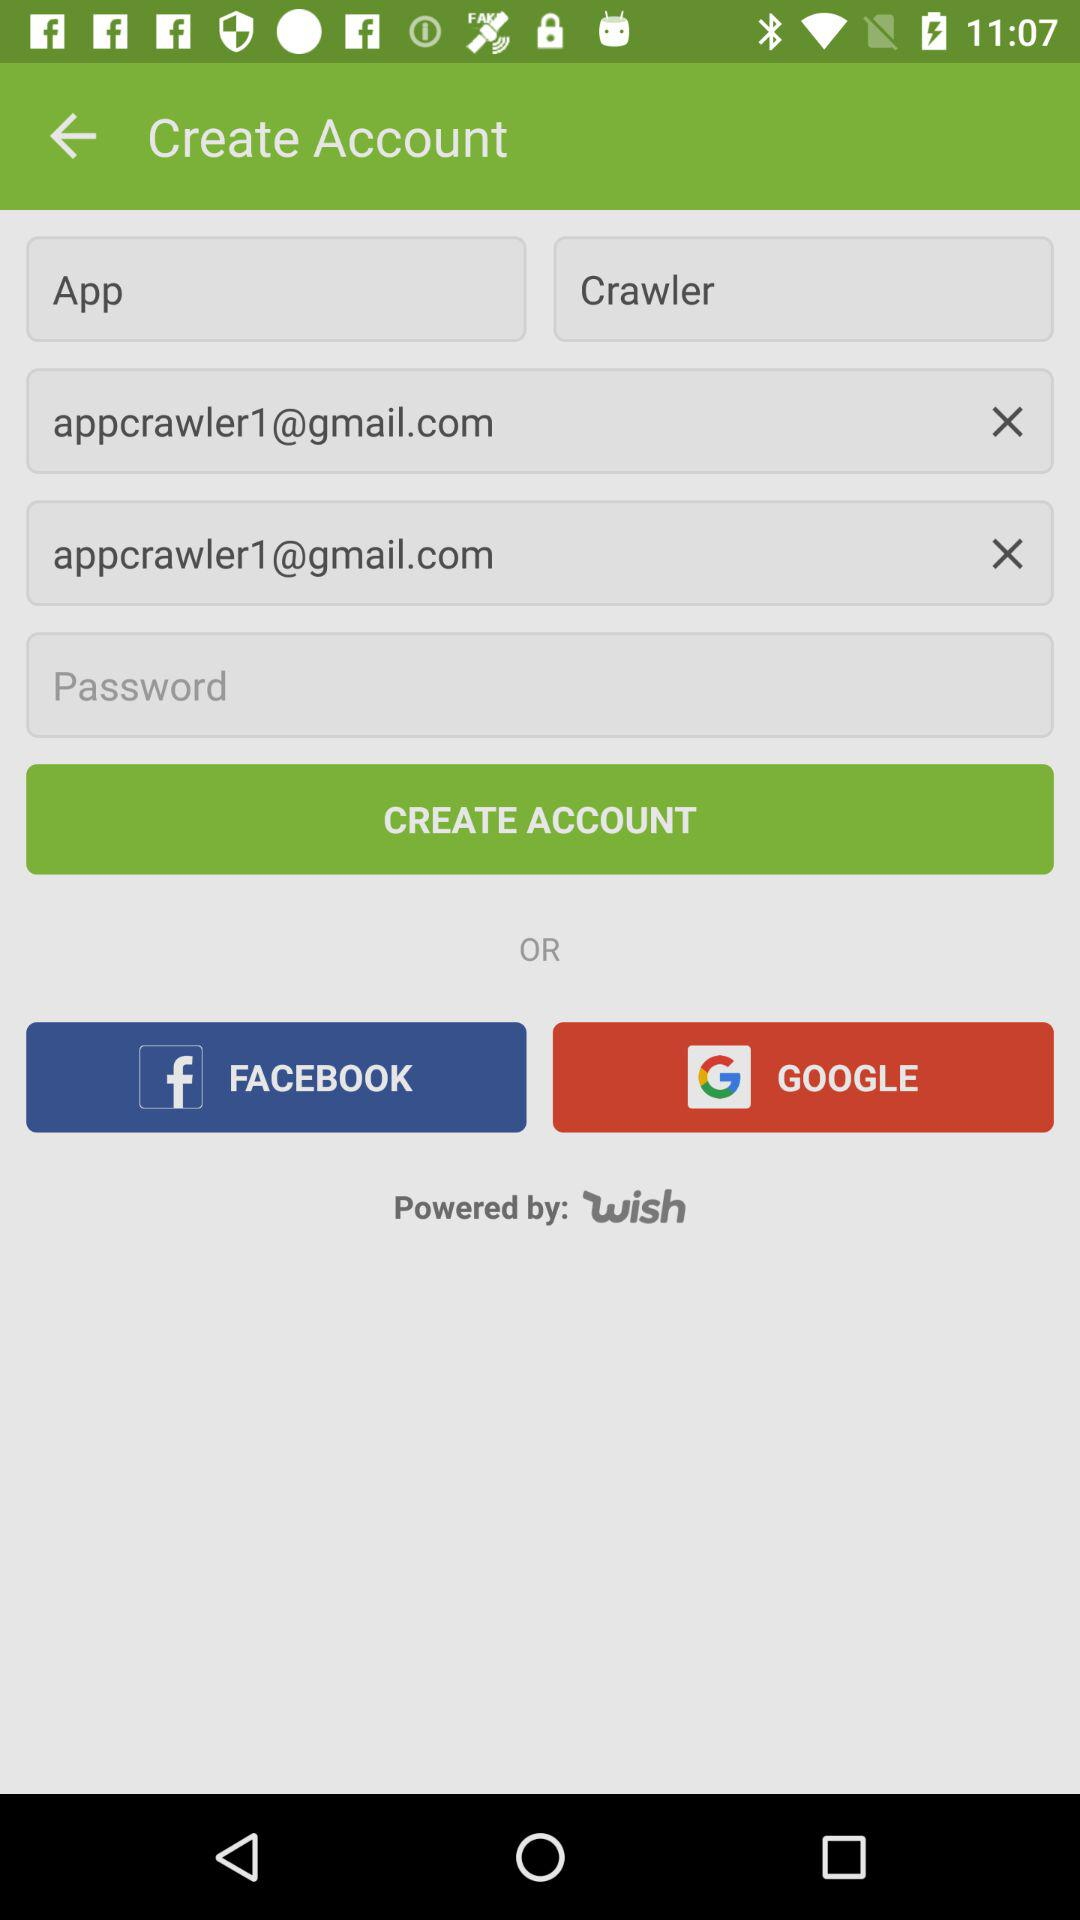What is the email address? The email address is appcrawler1@gmail.com. 